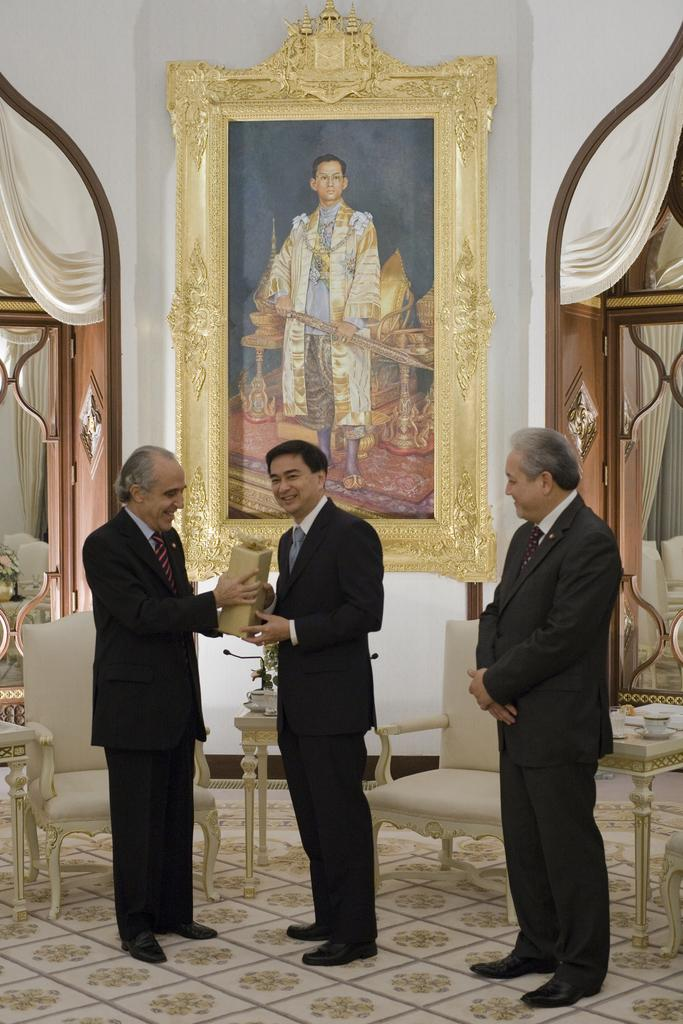How many people are in the image? There are three persons in the image. What is located behind the persons? There are chairs behind the persons. What can be seen on the wall in the image? There is a big frame of a person on the wall. What type of window treatment is present in the image? There are curtains near the doors. What type of chin can be seen on the person in the big frame? There is no chin visible in the image, as the big frame is of a person and not a chin. Is there any eggnog being served in the image? There is no mention of eggnog or any food or drink in the image. 